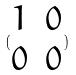Convert formula to latex. <formula><loc_0><loc_0><loc_500><loc_500>( \begin{matrix} 1 & 0 \\ 0 & 0 \end{matrix} )</formula> 